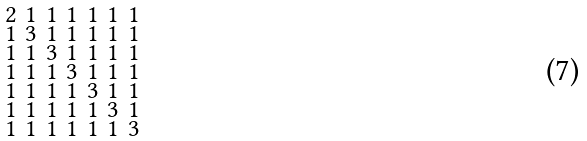<formula> <loc_0><loc_0><loc_500><loc_500>\begin{smallmatrix} 2 & 1 & 1 & 1 & 1 & 1 & 1 \\ 1 & 3 & 1 & 1 & 1 & 1 & 1 \\ 1 & 1 & 3 & 1 & 1 & 1 & 1 \\ 1 & 1 & 1 & 3 & 1 & 1 & 1 \\ 1 & 1 & 1 & 1 & 3 & 1 & 1 \\ 1 & 1 & 1 & 1 & 1 & 3 & 1 \\ 1 & 1 & 1 & 1 & 1 & 1 & 3 \end{smallmatrix}</formula> 